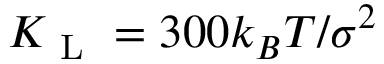<formula> <loc_0><loc_0><loc_500><loc_500>K _ { L } = 3 0 0 k _ { B } T / \sigma ^ { 2 }</formula> 